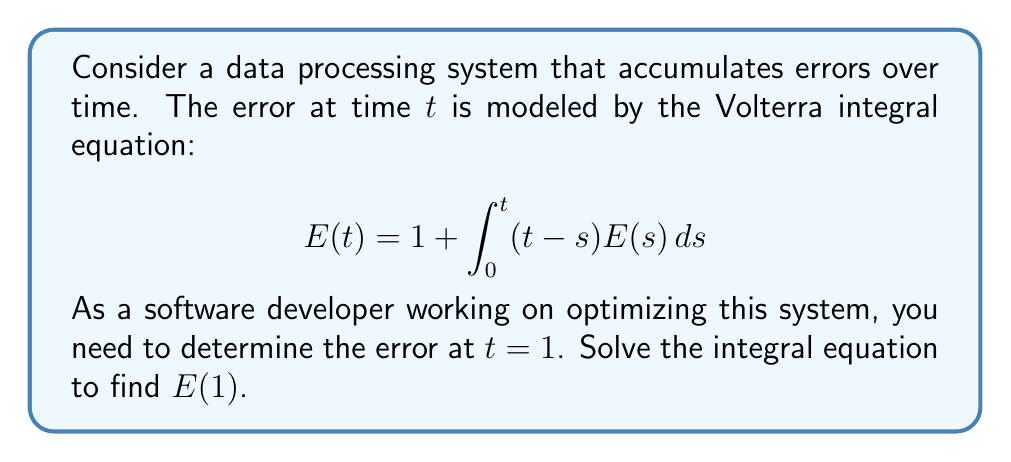Give your solution to this math problem. To solve this Volterra integral equation, we'll use the method of successive approximations:

1) Start with the initial approximation $E_0(t) = 1$

2) Substitute this into the right-hand side of the equation to get the next approximation:

   $$E_1(t) = 1 + \int_0^t (t-s) \cdot 1 ds = 1 + \frac{t^2}{2}$$

3) Repeat this process:

   $$E_2(t) = 1 + \int_0^t (t-s) \cdot (1 + \frac{s^2}{2}) ds$$
   $$= 1 + \frac{t^2}{2} + \frac{t^4}{24}$$

4) One more iteration:

   $$E_3(t) = 1 + \int_0^t (t-s) \cdot (1 + \frac{s^2}{2} + \frac{s^4}{24}) ds$$
   $$= 1 + \frac{t^2}{2} + \frac{t^4}{24} + \frac{t^6}{720}$$

5) We can see a pattern forming. The exact solution is:

   $$E(t) = 1 + \frac{t^2}{2!} + \frac{t^4}{4!} + \frac{t^6}{6!} + ...$$

6) This series is recognizable as the hyperbolic cosine function:

   $$E(t) = \cosh(t)$$

7) To find $E(1)$, we simply evaluate $\cosh(1)$:

   $$E(1) = \cosh(1) \approx 1.5430806348152437$$
Answer: $\cosh(1) \approx 1.5431$ 